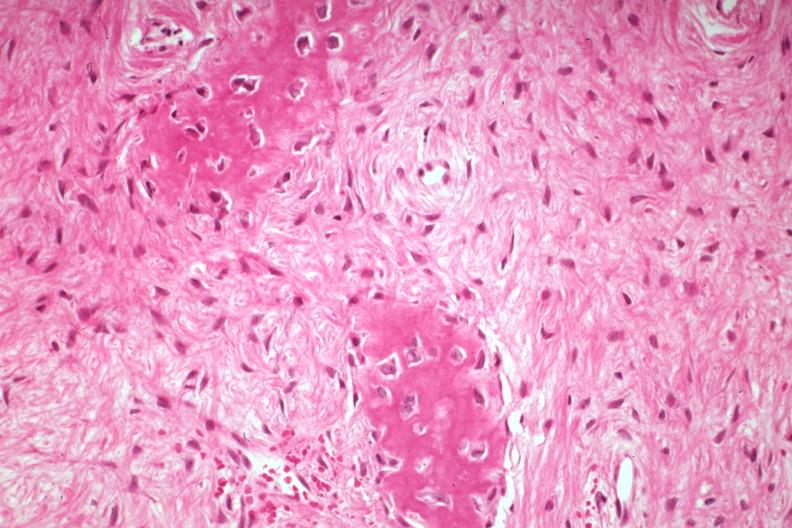does this image show high excessive fibrous callus in a non-union excellent granulation type tissue with collagen?
Answer the question using a single word or phrase. Yes 